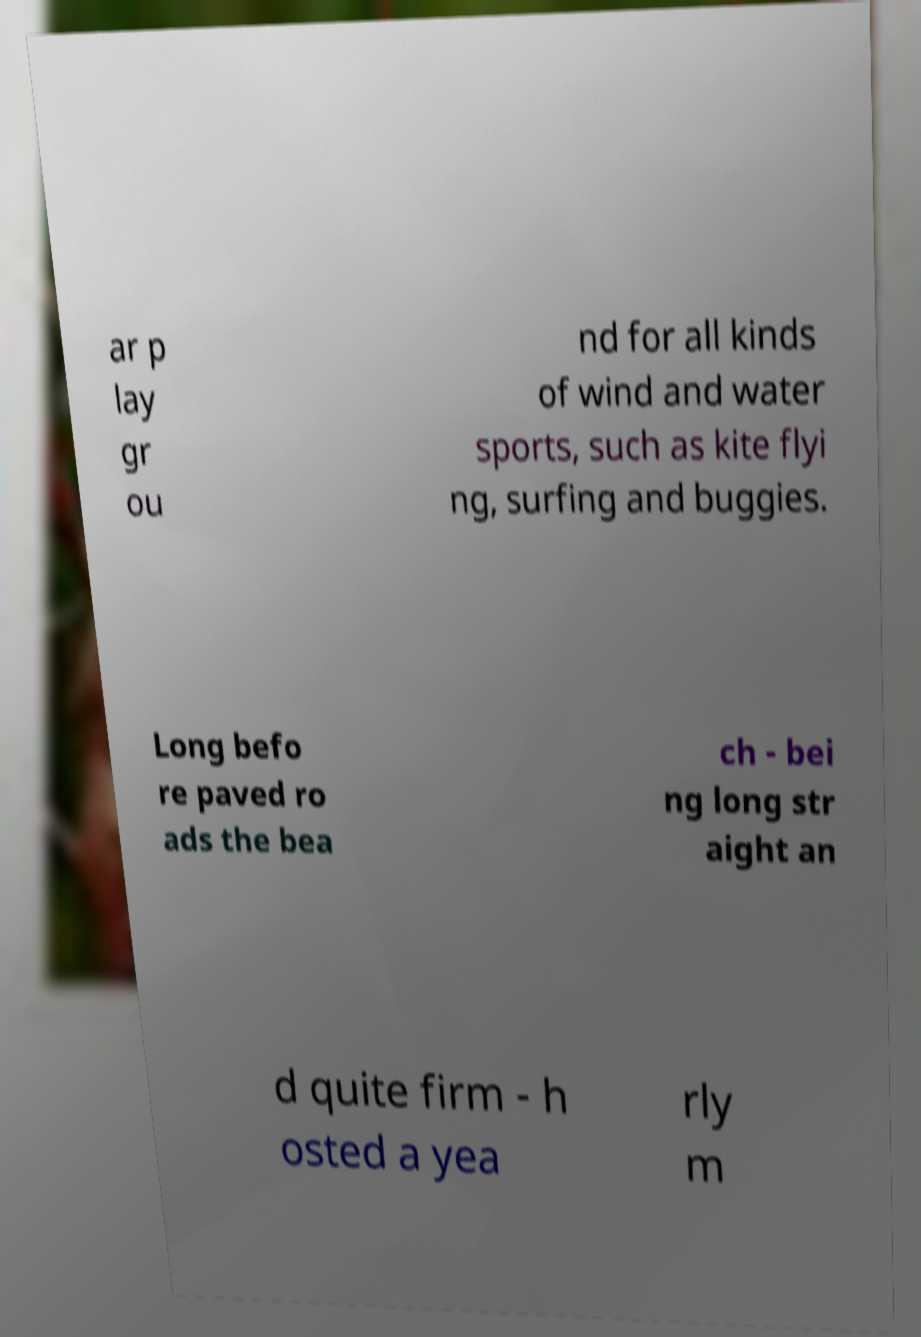Please identify and transcribe the text found in this image. ar p lay gr ou nd for all kinds of wind and water sports, such as kite flyi ng, surfing and buggies. Long befo re paved ro ads the bea ch - bei ng long str aight an d quite firm - h osted a yea rly m 